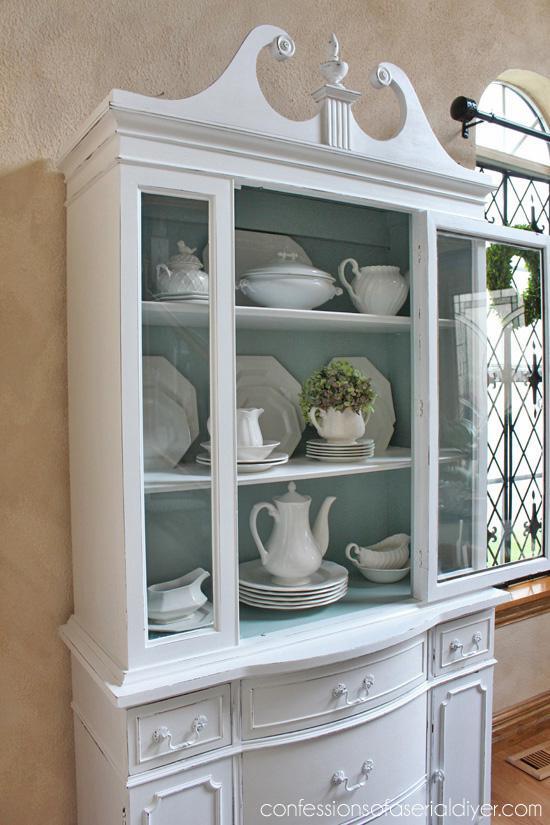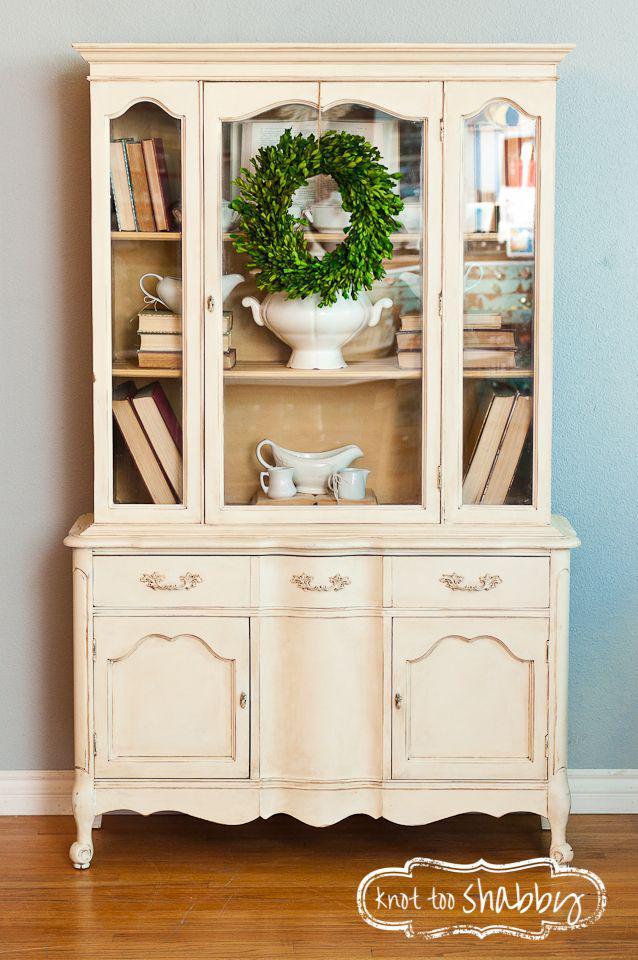The first image is the image on the left, the second image is the image on the right. Given the left and right images, does the statement "The right image has a cabinet with a green wreath hanging on it." hold true? Answer yes or no. Yes. The first image is the image on the left, the second image is the image on the right. Analyze the images presented: Is the assertion "A wreath is hanging on a white china cabinet." valid? Answer yes or no. Yes. 